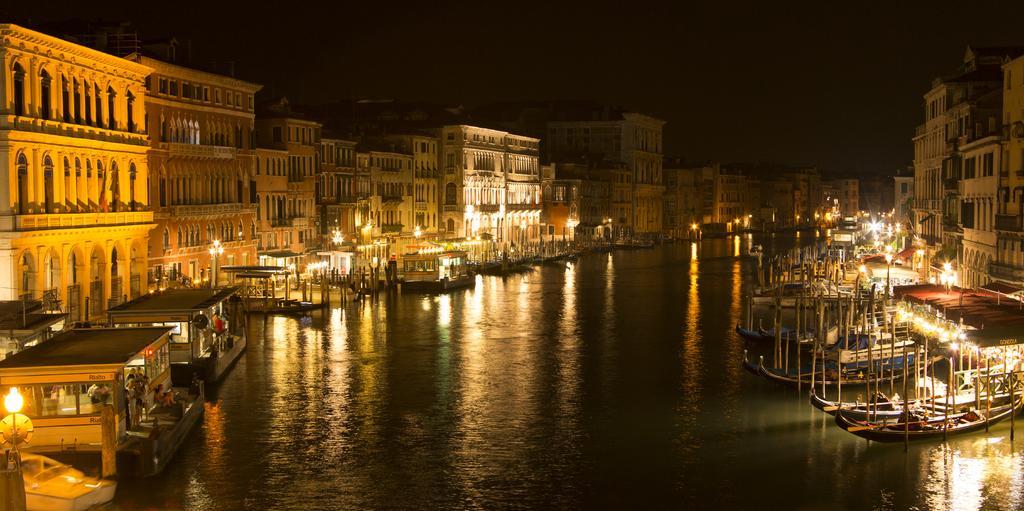Please provide a concise description of this image. In this image we can see a few people, there are ships on the river, there are buildings, lights, poles and the background is dark. 